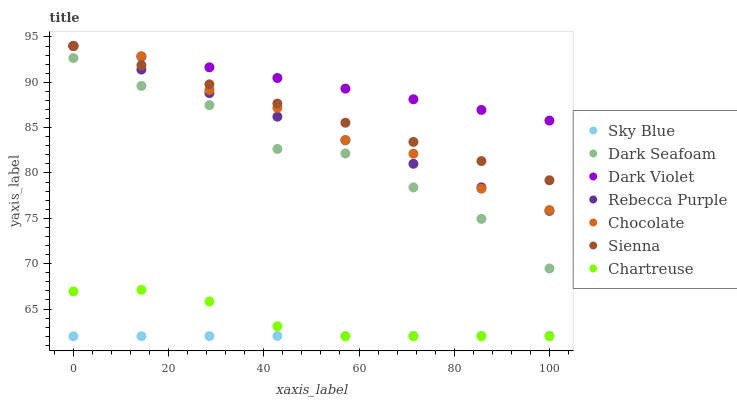Does Sky Blue have the minimum area under the curve?
Answer yes or no. Yes. Does Dark Violet have the maximum area under the curve?
Answer yes or no. Yes. Does Chocolate have the minimum area under the curve?
Answer yes or no. No. Does Chocolate have the maximum area under the curve?
Answer yes or no. No. Is Sky Blue the smoothest?
Answer yes or no. Yes. Is Dark Seafoam the roughest?
Answer yes or no. Yes. Is Dark Violet the smoothest?
Answer yes or no. No. Is Dark Violet the roughest?
Answer yes or no. No. Does Chartreuse have the lowest value?
Answer yes or no. Yes. Does Chocolate have the lowest value?
Answer yes or no. No. Does Rebecca Purple have the highest value?
Answer yes or no. Yes. Does Dark Seafoam have the highest value?
Answer yes or no. No. Is Sky Blue less than Rebecca Purple?
Answer yes or no. Yes. Is Dark Seafoam greater than Sky Blue?
Answer yes or no. Yes. Does Chocolate intersect Dark Violet?
Answer yes or no. Yes. Is Chocolate less than Dark Violet?
Answer yes or no. No. Is Chocolate greater than Dark Violet?
Answer yes or no. No. Does Sky Blue intersect Rebecca Purple?
Answer yes or no. No. 